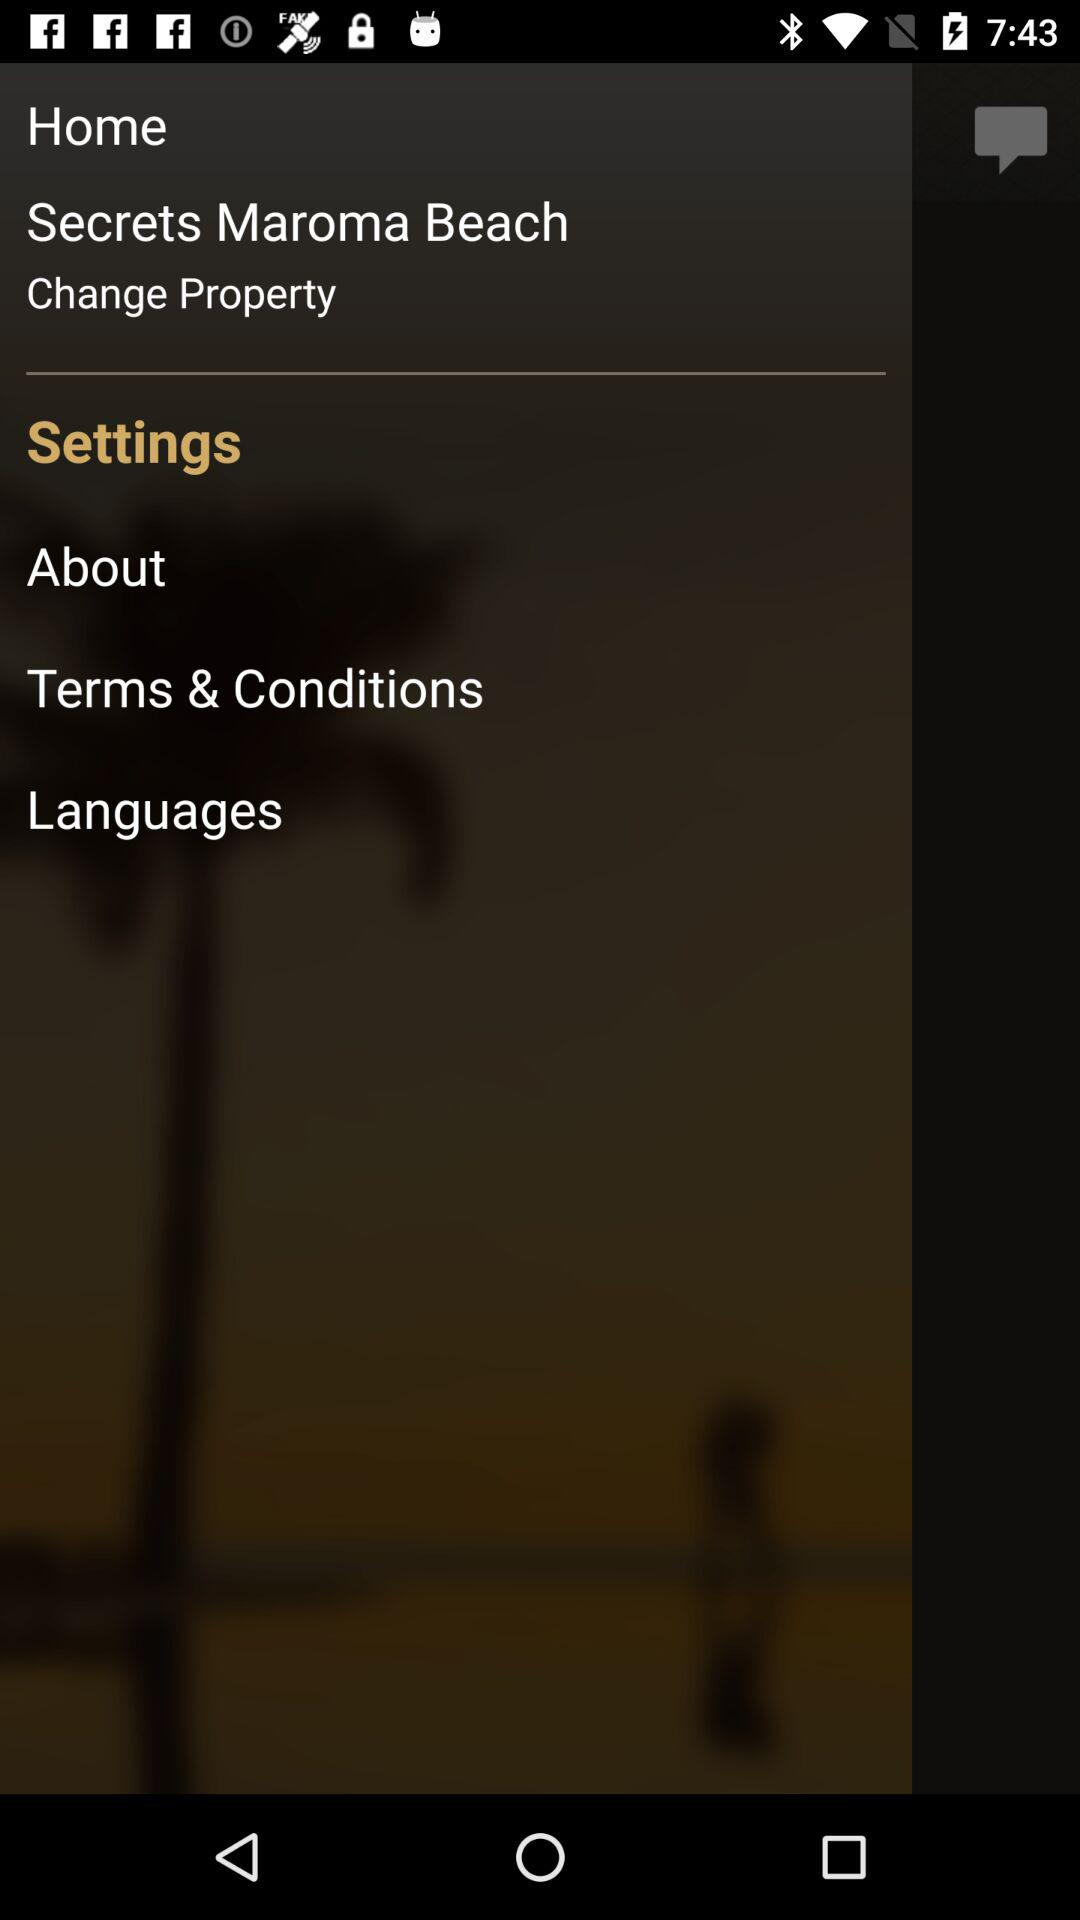What is the location? The location is Secrets Maroma Beach. 